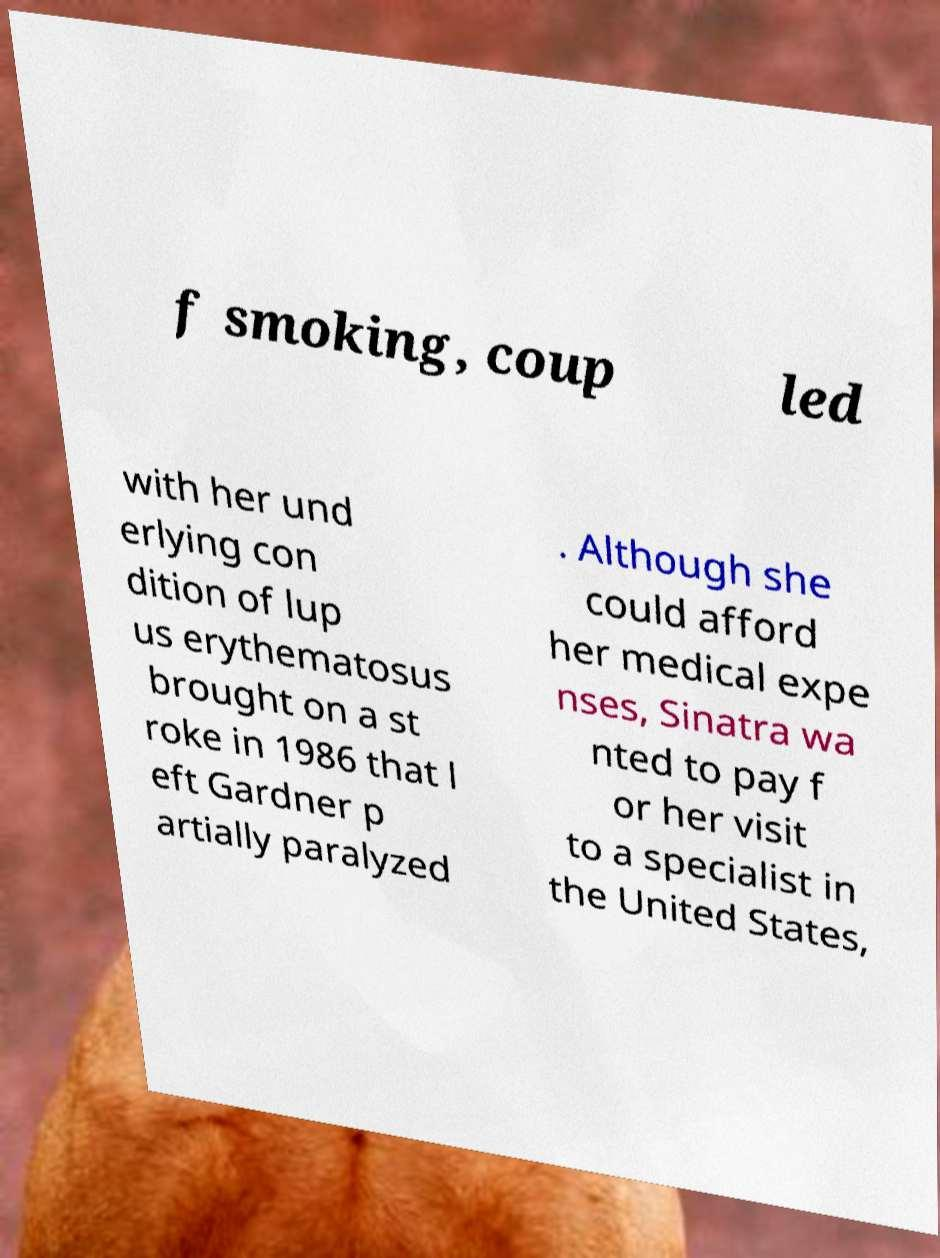What messages or text are displayed in this image? I need them in a readable, typed format. f smoking, coup led with her und erlying con dition of lup us erythematosus brought on a st roke in 1986 that l eft Gardner p artially paralyzed . Although she could afford her medical expe nses, Sinatra wa nted to pay f or her visit to a specialist in the United States, 